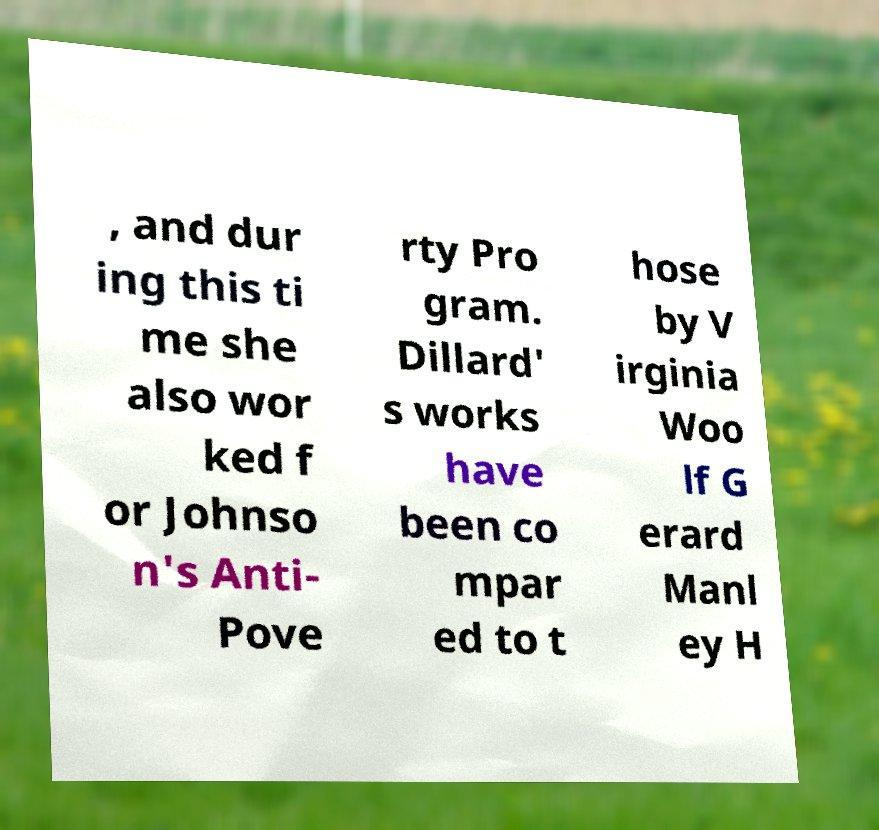Could you assist in decoding the text presented in this image and type it out clearly? , and dur ing this ti me she also wor ked f or Johnso n's Anti- Pove rty Pro gram. Dillard' s works have been co mpar ed to t hose by V irginia Woo lf G erard Manl ey H 